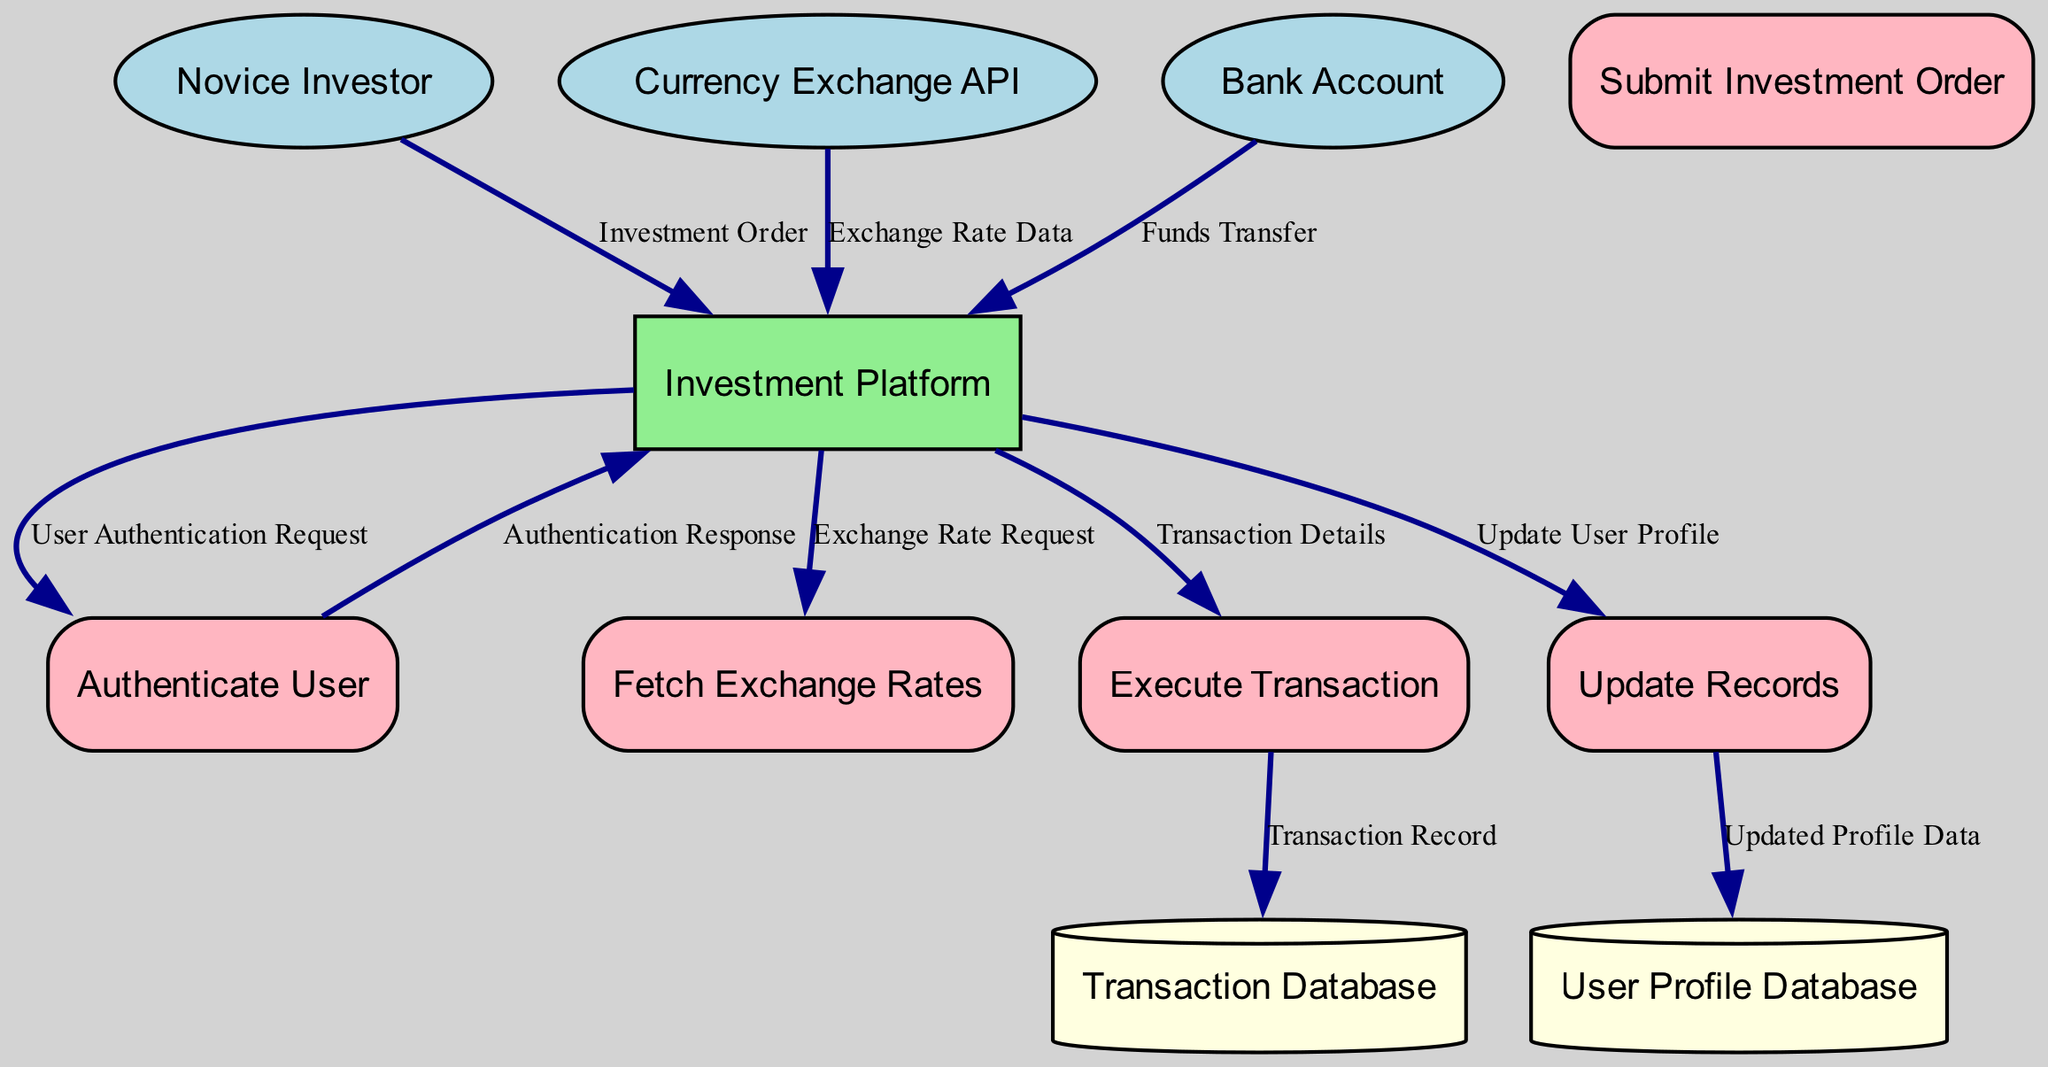What is the primary external entity involved in the currency exchange process? The diagram shows "Novice Investor" as the external entity initiating the investment transactions.
Answer: Novice Investor How many data stores are present in the diagram? By examining the diagram, we can identify "Transaction Database" and "User Profile Database" as the two data stores.
Answer: 2 What does the "Investment Order" data flow represent? This data flow represents the details of the transaction requested by the Novice Investor, which is submitted to the Investment Platform.
Answer: Details of the investment transaction Which process follows the "Authenticate User" process? After the "Authenticate User" process, the next process is "Fetch Exchange Rates," which is initiated to retrieve current exchange rates.
Answer: Fetch Exchange Rates What is the role of the "Currency Exchange API"? The "Currency Exchange API" provides real-time currency exchange rates to the Investment Platform when requested.
Answer: Providing exchange rates What type of data is stored in the "Transaction Database"? The "Transaction Database" stores records of all executed transactions related to currency exchanges conducted through the Investment Platform.
Answer: Executed transaction records How does the "Investment Platform" interact with the "Bank Account"? The "Investment Platform" receives a "Funds Transfer" from the Bank Account, which is necessary for executing the investment transaction.
Answer: Funds transfer What action does the "Update Records" process perform? The "Update Records" process updates both the Transaction Database and User Profile Database with new information related to the investor's transactions and profile.
Answer: Updating transaction and user profile records What is the purpose of the "Exchange Rate Request"? The "Exchange Rate Request" is a request sent from the Investment Platform to the Fetch Exchange Rates process to obtain current exchange rates.
Answer: Request to retrieve current exchange rates 